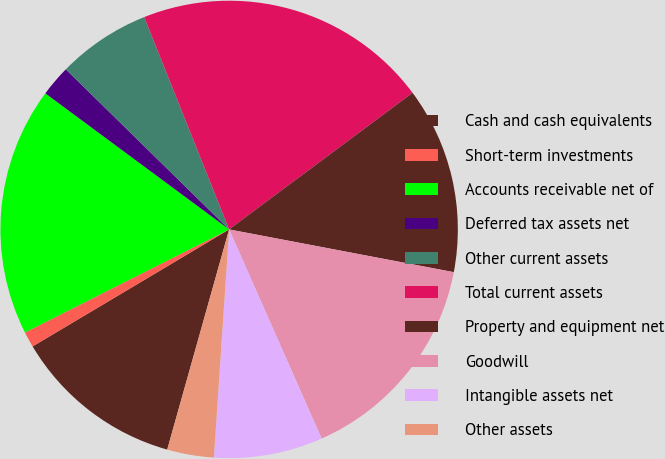<chart> <loc_0><loc_0><loc_500><loc_500><pie_chart><fcel>Cash and cash equivalents<fcel>Short-term investments<fcel>Accounts receivable net of<fcel>Deferred tax assets net<fcel>Other current assets<fcel>Total current assets<fcel>Property and equipment net<fcel>Goodwill<fcel>Intangible assets net<fcel>Other assets<nl><fcel>12.09%<fcel>1.11%<fcel>17.58%<fcel>2.2%<fcel>6.6%<fcel>20.87%<fcel>13.18%<fcel>15.38%<fcel>7.69%<fcel>3.3%<nl></chart> 